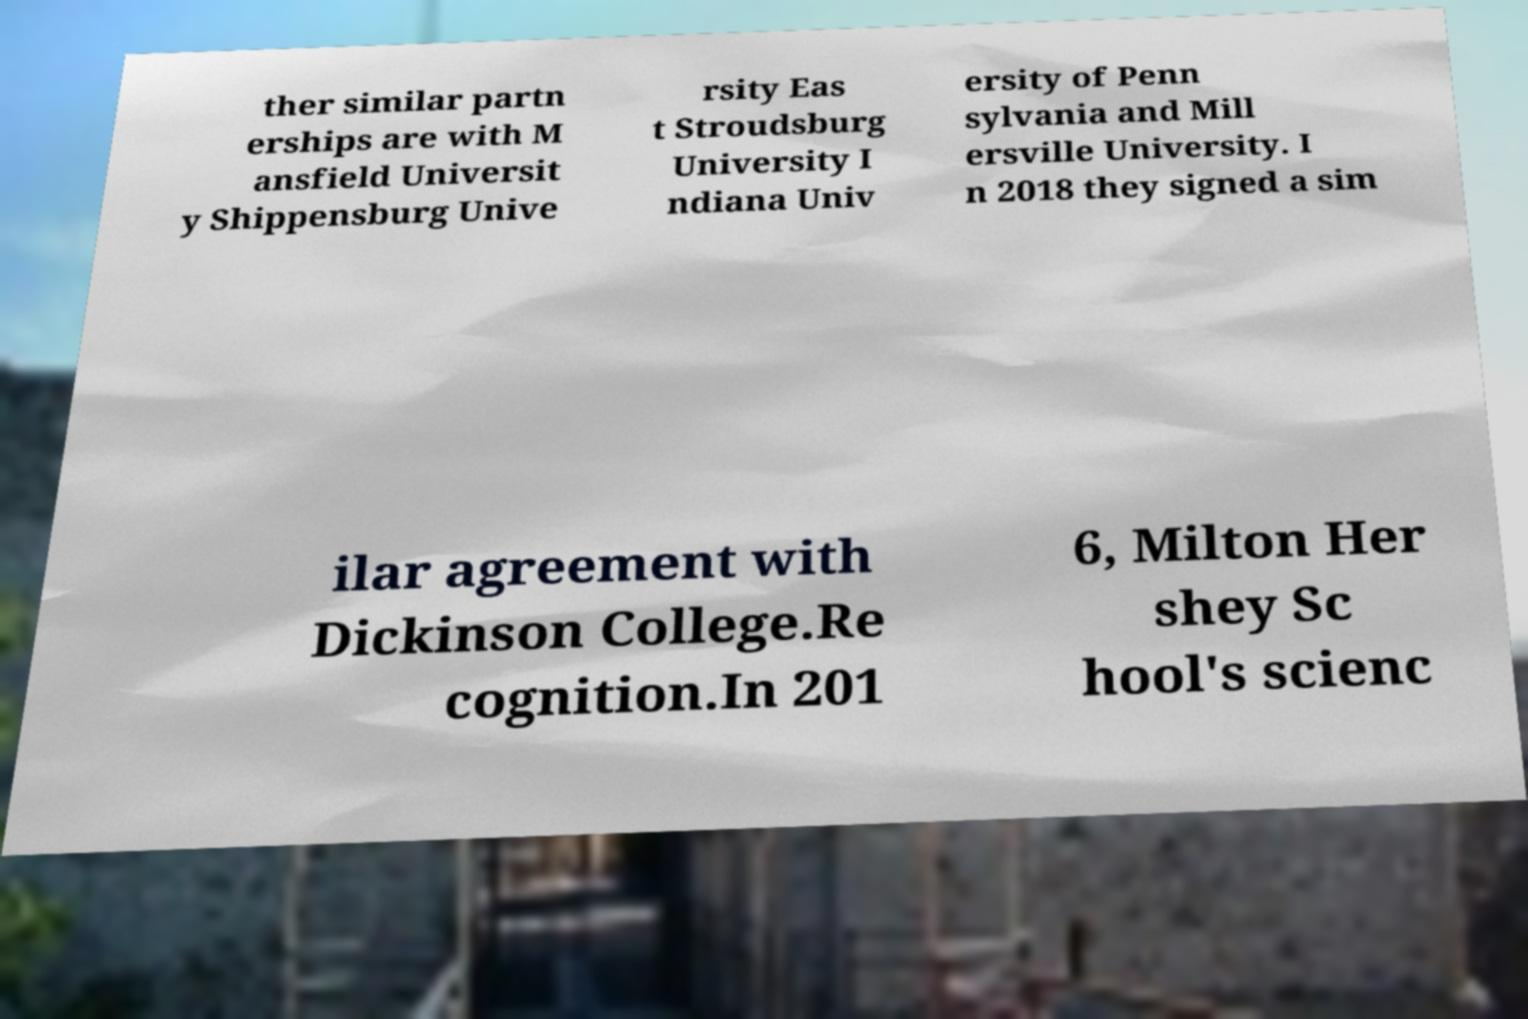Could you extract and type out the text from this image? ther similar partn erships are with M ansfield Universit y Shippensburg Unive rsity Eas t Stroudsburg University I ndiana Univ ersity of Penn sylvania and Mill ersville University. I n 2018 they signed a sim ilar agreement with Dickinson College.Re cognition.In 201 6, Milton Her shey Sc hool's scienc 